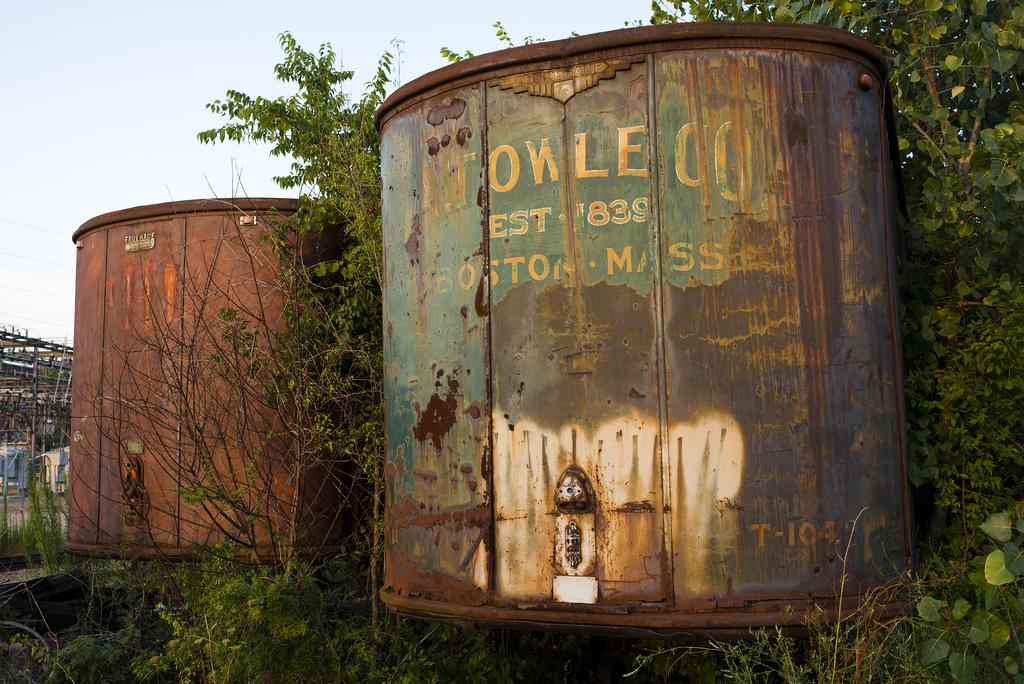What type of containers are present in the image? There are iron containers in the image. What can be seen between the containers? There are trees between the containers. What part of the natural environment is visible in the image? The sky is visible in the top left of the image. How many ladybugs can be seen on the trees in the image? There are no ladybugs present in the image; only trees are visible between the iron containers. What type of plant is being used to help the trees grow in the image? There is no plant being used to help the trees grow in the image; the trees are already present and visible between the iron containers. 